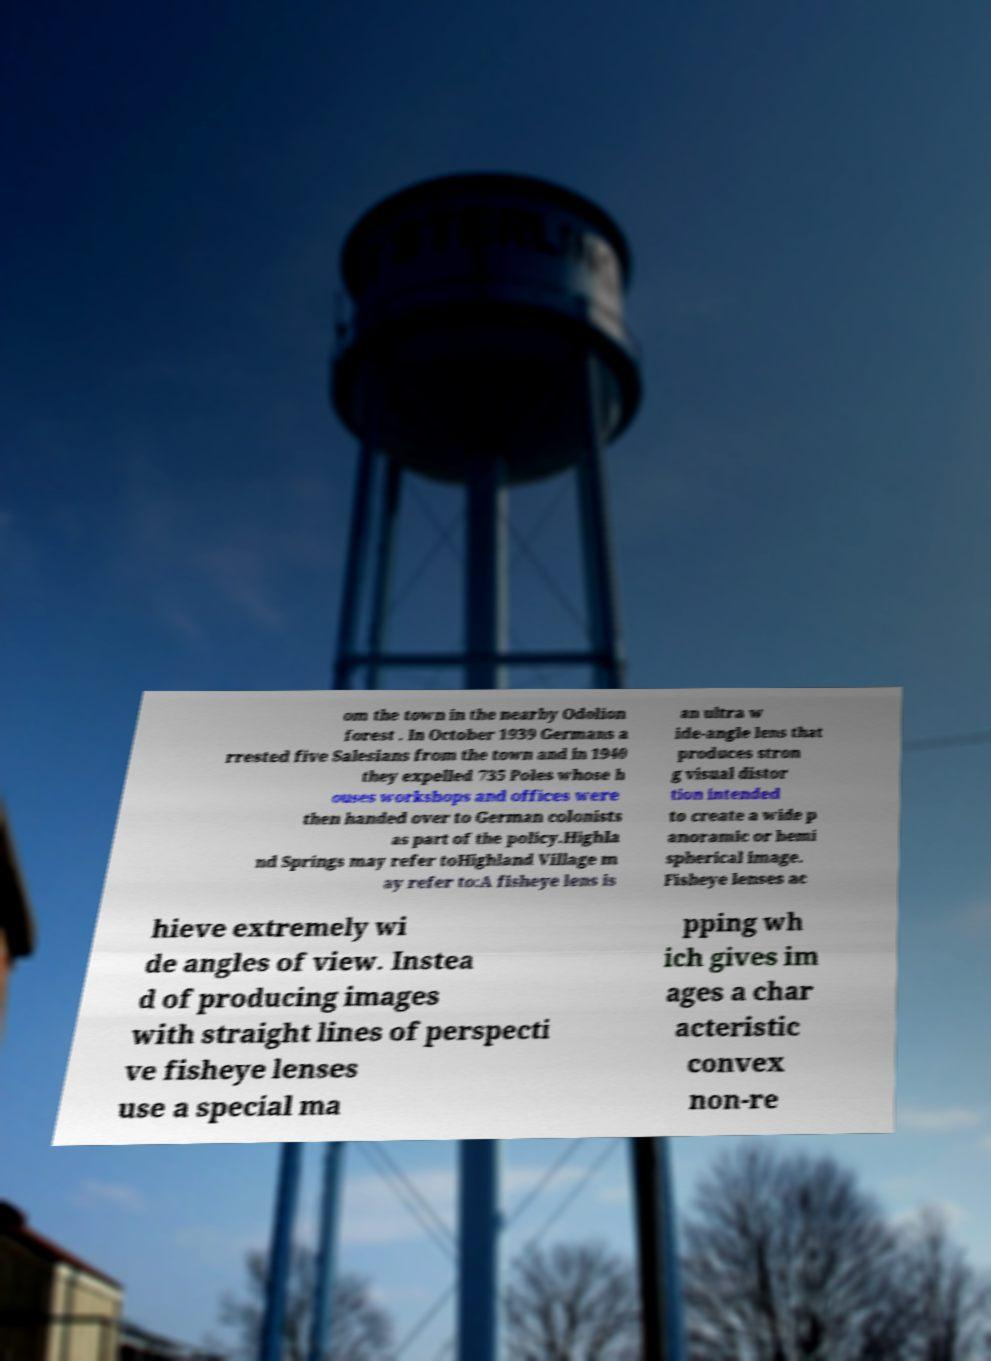Please identify and transcribe the text found in this image. om the town in the nearby Odolion forest . In October 1939 Germans a rrested five Salesians from the town and in 1940 they expelled 735 Poles whose h ouses workshops and offices were then handed over to German colonists as part of the policy.Highla nd Springs may refer toHighland Village m ay refer to:A fisheye lens is an ultra w ide-angle lens that produces stron g visual distor tion intended to create a wide p anoramic or hemi spherical image. Fisheye lenses ac hieve extremely wi de angles of view. Instea d of producing images with straight lines of perspecti ve fisheye lenses use a special ma pping wh ich gives im ages a char acteristic convex non-re 